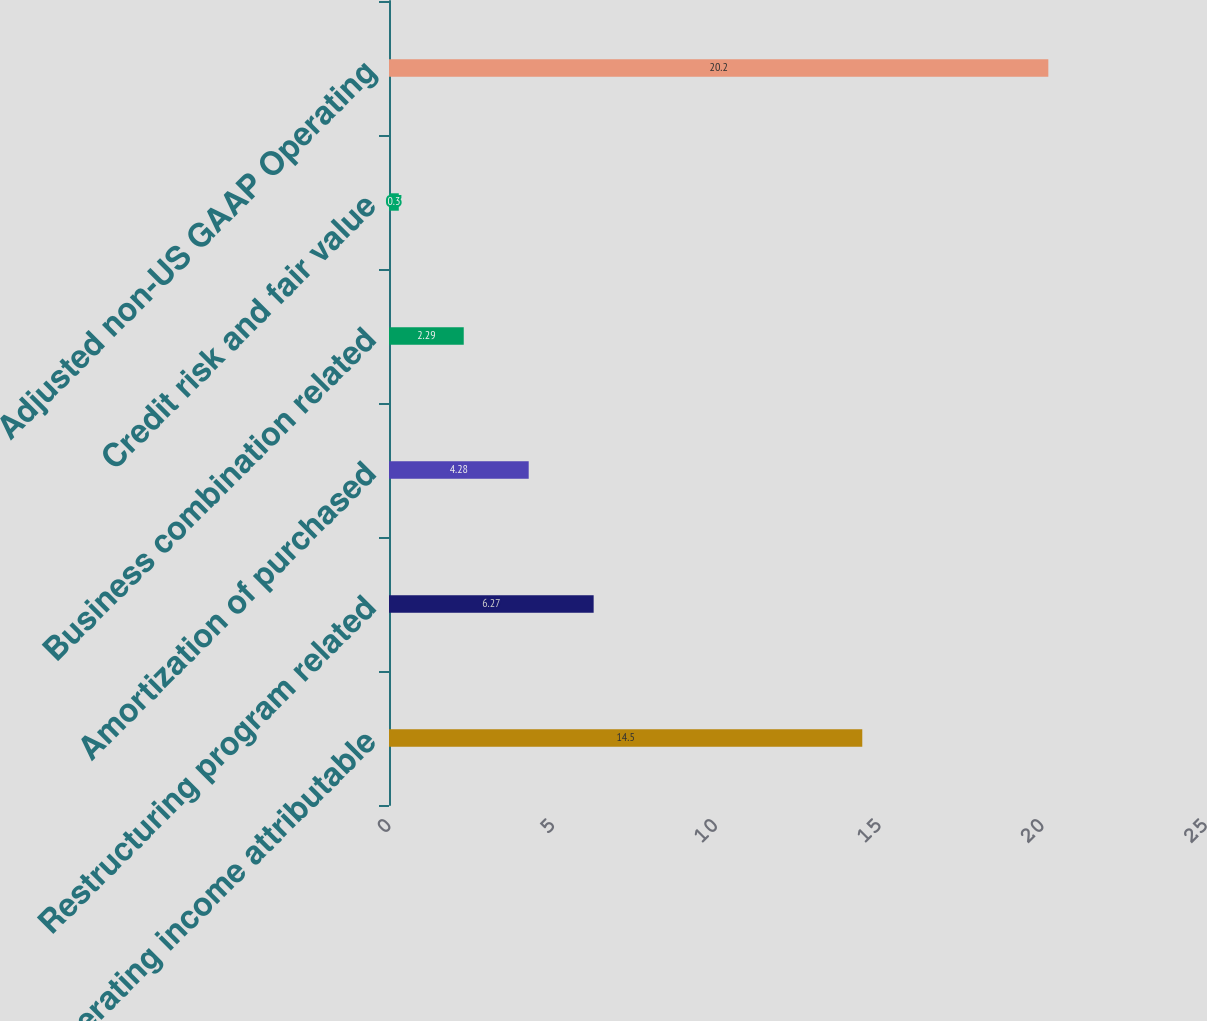<chart> <loc_0><loc_0><loc_500><loc_500><bar_chart><fcel>Operating income attributable<fcel>Restructuring program related<fcel>Amortization of purchased<fcel>Business combination related<fcel>Credit risk and fair value<fcel>Adjusted non-US GAAP Operating<nl><fcel>14.5<fcel>6.27<fcel>4.28<fcel>2.29<fcel>0.3<fcel>20.2<nl></chart> 